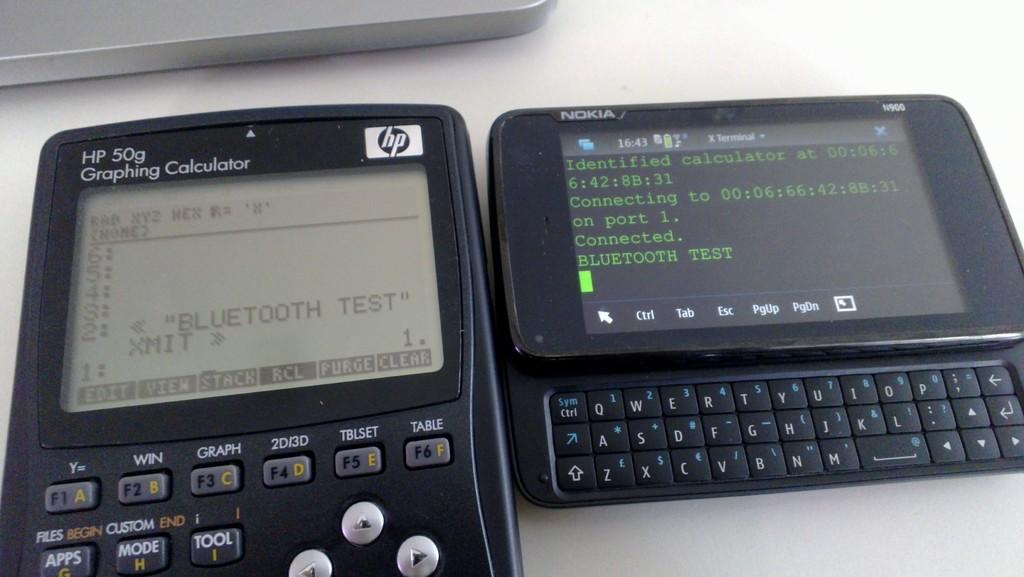<image>
Describe the image concisely. A black HP graphing calculator device beside an Nokia slide phone with the HP screen display featuring a Bluetooth test. 